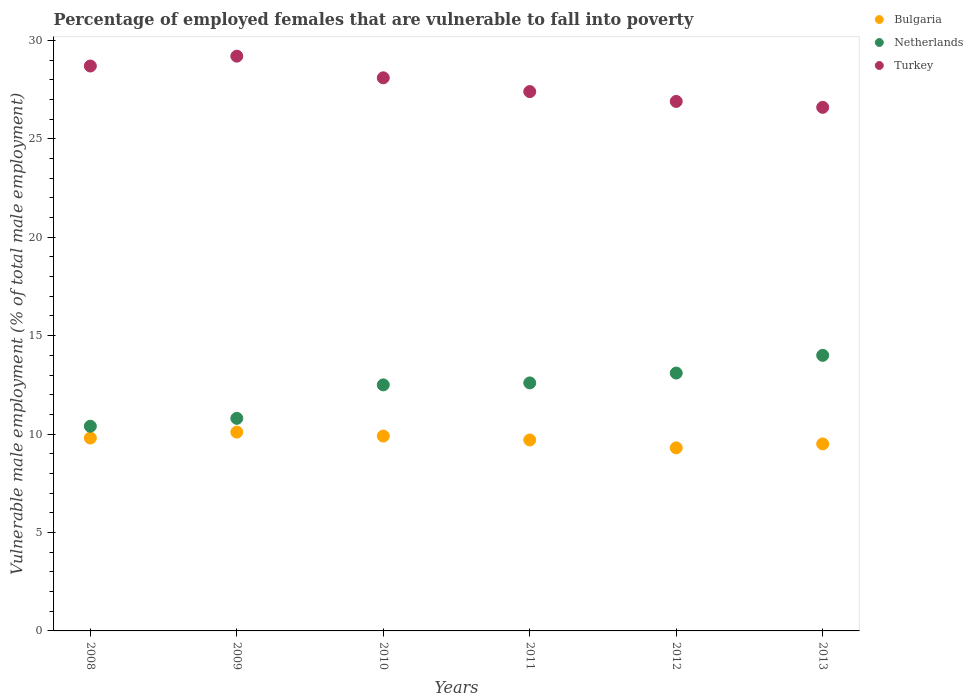How many different coloured dotlines are there?
Your answer should be compact. 3. Is the number of dotlines equal to the number of legend labels?
Your answer should be compact. Yes. What is the percentage of employed females who are vulnerable to fall into poverty in Netherlands in 2011?
Make the answer very short. 12.6. Across all years, what is the minimum percentage of employed females who are vulnerable to fall into poverty in Bulgaria?
Make the answer very short. 9.3. What is the total percentage of employed females who are vulnerable to fall into poverty in Turkey in the graph?
Keep it short and to the point. 166.9. What is the difference between the percentage of employed females who are vulnerable to fall into poverty in Netherlands in 2009 and that in 2013?
Keep it short and to the point. -3.2. What is the difference between the percentage of employed females who are vulnerable to fall into poverty in Netherlands in 2011 and the percentage of employed females who are vulnerable to fall into poverty in Turkey in 2008?
Your answer should be compact. -16.1. What is the average percentage of employed females who are vulnerable to fall into poverty in Netherlands per year?
Your response must be concise. 12.23. In the year 2013, what is the difference between the percentage of employed females who are vulnerable to fall into poverty in Turkey and percentage of employed females who are vulnerable to fall into poverty in Netherlands?
Give a very brief answer. 12.6. In how many years, is the percentage of employed females who are vulnerable to fall into poverty in Bulgaria greater than 5 %?
Offer a very short reply. 6. What is the ratio of the percentage of employed females who are vulnerable to fall into poverty in Netherlands in 2010 to that in 2011?
Your response must be concise. 0.99. Is the difference between the percentage of employed females who are vulnerable to fall into poverty in Turkey in 2011 and 2012 greater than the difference between the percentage of employed females who are vulnerable to fall into poverty in Netherlands in 2011 and 2012?
Ensure brevity in your answer.  Yes. What is the difference between the highest and the second highest percentage of employed females who are vulnerable to fall into poverty in Bulgaria?
Your answer should be very brief. 0.2. What is the difference between the highest and the lowest percentage of employed females who are vulnerable to fall into poverty in Bulgaria?
Offer a terse response. 0.8. Is the percentage of employed females who are vulnerable to fall into poverty in Turkey strictly greater than the percentage of employed females who are vulnerable to fall into poverty in Netherlands over the years?
Offer a terse response. Yes. Is the percentage of employed females who are vulnerable to fall into poverty in Bulgaria strictly less than the percentage of employed females who are vulnerable to fall into poverty in Turkey over the years?
Offer a very short reply. Yes. What is the difference between two consecutive major ticks on the Y-axis?
Offer a terse response. 5. Does the graph contain grids?
Offer a very short reply. No. Where does the legend appear in the graph?
Make the answer very short. Top right. How many legend labels are there?
Give a very brief answer. 3. What is the title of the graph?
Ensure brevity in your answer.  Percentage of employed females that are vulnerable to fall into poverty. Does "Vanuatu" appear as one of the legend labels in the graph?
Give a very brief answer. No. What is the label or title of the X-axis?
Your answer should be very brief. Years. What is the label or title of the Y-axis?
Your answer should be compact. Vulnerable male employment (% of total male employment). What is the Vulnerable male employment (% of total male employment) of Bulgaria in 2008?
Your response must be concise. 9.8. What is the Vulnerable male employment (% of total male employment) in Netherlands in 2008?
Make the answer very short. 10.4. What is the Vulnerable male employment (% of total male employment) in Turkey in 2008?
Offer a very short reply. 28.7. What is the Vulnerable male employment (% of total male employment) in Bulgaria in 2009?
Provide a succinct answer. 10.1. What is the Vulnerable male employment (% of total male employment) of Netherlands in 2009?
Offer a terse response. 10.8. What is the Vulnerable male employment (% of total male employment) in Turkey in 2009?
Offer a very short reply. 29.2. What is the Vulnerable male employment (% of total male employment) in Bulgaria in 2010?
Make the answer very short. 9.9. What is the Vulnerable male employment (% of total male employment) of Netherlands in 2010?
Give a very brief answer. 12.5. What is the Vulnerable male employment (% of total male employment) of Turkey in 2010?
Your answer should be compact. 28.1. What is the Vulnerable male employment (% of total male employment) of Bulgaria in 2011?
Offer a very short reply. 9.7. What is the Vulnerable male employment (% of total male employment) in Netherlands in 2011?
Provide a short and direct response. 12.6. What is the Vulnerable male employment (% of total male employment) in Turkey in 2011?
Provide a succinct answer. 27.4. What is the Vulnerable male employment (% of total male employment) of Bulgaria in 2012?
Provide a short and direct response. 9.3. What is the Vulnerable male employment (% of total male employment) in Netherlands in 2012?
Ensure brevity in your answer.  13.1. What is the Vulnerable male employment (% of total male employment) of Turkey in 2012?
Keep it short and to the point. 26.9. What is the Vulnerable male employment (% of total male employment) of Turkey in 2013?
Your answer should be compact. 26.6. Across all years, what is the maximum Vulnerable male employment (% of total male employment) of Bulgaria?
Ensure brevity in your answer.  10.1. Across all years, what is the maximum Vulnerable male employment (% of total male employment) of Turkey?
Your answer should be compact. 29.2. Across all years, what is the minimum Vulnerable male employment (% of total male employment) of Bulgaria?
Your answer should be compact. 9.3. Across all years, what is the minimum Vulnerable male employment (% of total male employment) of Netherlands?
Offer a terse response. 10.4. Across all years, what is the minimum Vulnerable male employment (% of total male employment) of Turkey?
Your answer should be very brief. 26.6. What is the total Vulnerable male employment (% of total male employment) in Bulgaria in the graph?
Offer a terse response. 58.3. What is the total Vulnerable male employment (% of total male employment) of Netherlands in the graph?
Your response must be concise. 73.4. What is the total Vulnerable male employment (% of total male employment) in Turkey in the graph?
Offer a very short reply. 166.9. What is the difference between the Vulnerable male employment (% of total male employment) in Bulgaria in 2008 and that in 2009?
Make the answer very short. -0.3. What is the difference between the Vulnerable male employment (% of total male employment) of Netherlands in 2008 and that in 2009?
Give a very brief answer. -0.4. What is the difference between the Vulnerable male employment (% of total male employment) in Turkey in 2008 and that in 2009?
Keep it short and to the point. -0.5. What is the difference between the Vulnerable male employment (% of total male employment) in Bulgaria in 2008 and that in 2010?
Offer a terse response. -0.1. What is the difference between the Vulnerable male employment (% of total male employment) of Bulgaria in 2008 and that in 2011?
Offer a very short reply. 0.1. What is the difference between the Vulnerable male employment (% of total male employment) in Turkey in 2008 and that in 2011?
Give a very brief answer. 1.3. What is the difference between the Vulnerable male employment (% of total male employment) in Bulgaria in 2008 and that in 2012?
Ensure brevity in your answer.  0.5. What is the difference between the Vulnerable male employment (% of total male employment) in Netherlands in 2008 and that in 2013?
Give a very brief answer. -3.6. What is the difference between the Vulnerable male employment (% of total male employment) of Bulgaria in 2009 and that in 2010?
Your answer should be very brief. 0.2. What is the difference between the Vulnerable male employment (% of total male employment) in Netherlands in 2009 and that in 2010?
Your answer should be very brief. -1.7. What is the difference between the Vulnerable male employment (% of total male employment) in Netherlands in 2009 and that in 2013?
Keep it short and to the point. -3.2. What is the difference between the Vulnerable male employment (% of total male employment) in Turkey in 2009 and that in 2013?
Provide a succinct answer. 2.6. What is the difference between the Vulnerable male employment (% of total male employment) of Bulgaria in 2010 and that in 2011?
Your answer should be very brief. 0.2. What is the difference between the Vulnerable male employment (% of total male employment) in Netherlands in 2010 and that in 2011?
Offer a terse response. -0.1. What is the difference between the Vulnerable male employment (% of total male employment) of Bulgaria in 2010 and that in 2012?
Offer a very short reply. 0.6. What is the difference between the Vulnerable male employment (% of total male employment) of Netherlands in 2010 and that in 2012?
Your answer should be very brief. -0.6. What is the difference between the Vulnerable male employment (% of total male employment) of Netherlands in 2010 and that in 2013?
Your answer should be compact. -1.5. What is the difference between the Vulnerable male employment (% of total male employment) of Netherlands in 2011 and that in 2012?
Your answer should be very brief. -0.5. What is the difference between the Vulnerable male employment (% of total male employment) in Netherlands in 2012 and that in 2013?
Give a very brief answer. -0.9. What is the difference between the Vulnerable male employment (% of total male employment) in Bulgaria in 2008 and the Vulnerable male employment (% of total male employment) in Turkey in 2009?
Give a very brief answer. -19.4. What is the difference between the Vulnerable male employment (% of total male employment) of Netherlands in 2008 and the Vulnerable male employment (% of total male employment) of Turkey in 2009?
Make the answer very short. -18.8. What is the difference between the Vulnerable male employment (% of total male employment) of Bulgaria in 2008 and the Vulnerable male employment (% of total male employment) of Netherlands in 2010?
Your response must be concise. -2.7. What is the difference between the Vulnerable male employment (% of total male employment) in Bulgaria in 2008 and the Vulnerable male employment (% of total male employment) in Turkey in 2010?
Offer a terse response. -18.3. What is the difference between the Vulnerable male employment (% of total male employment) of Netherlands in 2008 and the Vulnerable male employment (% of total male employment) of Turkey in 2010?
Offer a terse response. -17.7. What is the difference between the Vulnerable male employment (% of total male employment) of Bulgaria in 2008 and the Vulnerable male employment (% of total male employment) of Netherlands in 2011?
Give a very brief answer. -2.8. What is the difference between the Vulnerable male employment (% of total male employment) in Bulgaria in 2008 and the Vulnerable male employment (% of total male employment) in Turkey in 2011?
Provide a succinct answer. -17.6. What is the difference between the Vulnerable male employment (% of total male employment) of Netherlands in 2008 and the Vulnerable male employment (% of total male employment) of Turkey in 2011?
Your response must be concise. -17. What is the difference between the Vulnerable male employment (% of total male employment) in Bulgaria in 2008 and the Vulnerable male employment (% of total male employment) in Netherlands in 2012?
Provide a short and direct response. -3.3. What is the difference between the Vulnerable male employment (% of total male employment) of Bulgaria in 2008 and the Vulnerable male employment (% of total male employment) of Turkey in 2012?
Your response must be concise. -17.1. What is the difference between the Vulnerable male employment (% of total male employment) in Netherlands in 2008 and the Vulnerable male employment (% of total male employment) in Turkey in 2012?
Offer a very short reply. -16.5. What is the difference between the Vulnerable male employment (% of total male employment) of Bulgaria in 2008 and the Vulnerable male employment (% of total male employment) of Netherlands in 2013?
Ensure brevity in your answer.  -4.2. What is the difference between the Vulnerable male employment (% of total male employment) of Bulgaria in 2008 and the Vulnerable male employment (% of total male employment) of Turkey in 2013?
Provide a succinct answer. -16.8. What is the difference between the Vulnerable male employment (% of total male employment) in Netherlands in 2008 and the Vulnerable male employment (% of total male employment) in Turkey in 2013?
Your answer should be very brief. -16.2. What is the difference between the Vulnerable male employment (% of total male employment) of Netherlands in 2009 and the Vulnerable male employment (% of total male employment) of Turkey in 2010?
Ensure brevity in your answer.  -17.3. What is the difference between the Vulnerable male employment (% of total male employment) of Bulgaria in 2009 and the Vulnerable male employment (% of total male employment) of Turkey in 2011?
Offer a terse response. -17.3. What is the difference between the Vulnerable male employment (% of total male employment) of Netherlands in 2009 and the Vulnerable male employment (% of total male employment) of Turkey in 2011?
Provide a succinct answer. -16.6. What is the difference between the Vulnerable male employment (% of total male employment) of Bulgaria in 2009 and the Vulnerable male employment (% of total male employment) of Netherlands in 2012?
Offer a very short reply. -3. What is the difference between the Vulnerable male employment (% of total male employment) in Bulgaria in 2009 and the Vulnerable male employment (% of total male employment) in Turkey in 2012?
Offer a very short reply. -16.8. What is the difference between the Vulnerable male employment (% of total male employment) in Netherlands in 2009 and the Vulnerable male employment (% of total male employment) in Turkey in 2012?
Your answer should be compact. -16.1. What is the difference between the Vulnerable male employment (% of total male employment) of Bulgaria in 2009 and the Vulnerable male employment (% of total male employment) of Turkey in 2013?
Provide a short and direct response. -16.5. What is the difference between the Vulnerable male employment (% of total male employment) in Netherlands in 2009 and the Vulnerable male employment (% of total male employment) in Turkey in 2013?
Your answer should be compact. -15.8. What is the difference between the Vulnerable male employment (% of total male employment) of Bulgaria in 2010 and the Vulnerable male employment (% of total male employment) of Turkey in 2011?
Your answer should be very brief. -17.5. What is the difference between the Vulnerable male employment (% of total male employment) of Netherlands in 2010 and the Vulnerable male employment (% of total male employment) of Turkey in 2011?
Offer a terse response. -14.9. What is the difference between the Vulnerable male employment (% of total male employment) in Bulgaria in 2010 and the Vulnerable male employment (% of total male employment) in Turkey in 2012?
Your response must be concise. -17. What is the difference between the Vulnerable male employment (% of total male employment) in Netherlands in 2010 and the Vulnerable male employment (% of total male employment) in Turkey in 2012?
Keep it short and to the point. -14.4. What is the difference between the Vulnerable male employment (% of total male employment) of Bulgaria in 2010 and the Vulnerable male employment (% of total male employment) of Turkey in 2013?
Your answer should be very brief. -16.7. What is the difference between the Vulnerable male employment (% of total male employment) in Netherlands in 2010 and the Vulnerable male employment (% of total male employment) in Turkey in 2013?
Your answer should be compact. -14.1. What is the difference between the Vulnerable male employment (% of total male employment) in Bulgaria in 2011 and the Vulnerable male employment (% of total male employment) in Turkey in 2012?
Your response must be concise. -17.2. What is the difference between the Vulnerable male employment (% of total male employment) of Netherlands in 2011 and the Vulnerable male employment (% of total male employment) of Turkey in 2012?
Your answer should be compact. -14.3. What is the difference between the Vulnerable male employment (% of total male employment) of Bulgaria in 2011 and the Vulnerable male employment (% of total male employment) of Netherlands in 2013?
Ensure brevity in your answer.  -4.3. What is the difference between the Vulnerable male employment (% of total male employment) of Bulgaria in 2011 and the Vulnerable male employment (% of total male employment) of Turkey in 2013?
Your answer should be compact. -16.9. What is the difference between the Vulnerable male employment (% of total male employment) of Netherlands in 2011 and the Vulnerable male employment (% of total male employment) of Turkey in 2013?
Provide a succinct answer. -14. What is the difference between the Vulnerable male employment (% of total male employment) in Bulgaria in 2012 and the Vulnerable male employment (% of total male employment) in Turkey in 2013?
Give a very brief answer. -17.3. What is the difference between the Vulnerable male employment (% of total male employment) in Netherlands in 2012 and the Vulnerable male employment (% of total male employment) in Turkey in 2013?
Keep it short and to the point. -13.5. What is the average Vulnerable male employment (% of total male employment) of Bulgaria per year?
Offer a terse response. 9.72. What is the average Vulnerable male employment (% of total male employment) in Netherlands per year?
Give a very brief answer. 12.23. What is the average Vulnerable male employment (% of total male employment) in Turkey per year?
Ensure brevity in your answer.  27.82. In the year 2008, what is the difference between the Vulnerable male employment (% of total male employment) in Bulgaria and Vulnerable male employment (% of total male employment) in Netherlands?
Provide a short and direct response. -0.6. In the year 2008, what is the difference between the Vulnerable male employment (% of total male employment) of Bulgaria and Vulnerable male employment (% of total male employment) of Turkey?
Keep it short and to the point. -18.9. In the year 2008, what is the difference between the Vulnerable male employment (% of total male employment) of Netherlands and Vulnerable male employment (% of total male employment) of Turkey?
Offer a very short reply. -18.3. In the year 2009, what is the difference between the Vulnerable male employment (% of total male employment) in Bulgaria and Vulnerable male employment (% of total male employment) in Turkey?
Keep it short and to the point. -19.1. In the year 2009, what is the difference between the Vulnerable male employment (% of total male employment) in Netherlands and Vulnerable male employment (% of total male employment) in Turkey?
Provide a short and direct response. -18.4. In the year 2010, what is the difference between the Vulnerable male employment (% of total male employment) of Bulgaria and Vulnerable male employment (% of total male employment) of Turkey?
Ensure brevity in your answer.  -18.2. In the year 2010, what is the difference between the Vulnerable male employment (% of total male employment) in Netherlands and Vulnerable male employment (% of total male employment) in Turkey?
Your answer should be compact. -15.6. In the year 2011, what is the difference between the Vulnerable male employment (% of total male employment) of Bulgaria and Vulnerable male employment (% of total male employment) of Netherlands?
Keep it short and to the point. -2.9. In the year 2011, what is the difference between the Vulnerable male employment (% of total male employment) of Bulgaria and Vulnerable male employment (% of total male employment) of Turkey?
Keep it short and to the point. -17.7. In the year 2011, what is the difference between the Vulnerable male employment (% of total male employment) of Netherlands and Vulnerable male employment (% of total male employment) of Turkey?
Your answer should be compact. -14.8. In the year 2012, what is the difference between the Vulnerable male employment (% of total male employment) in Bulgaria and Vulnerable male employment (% of total male employment) in Turkey?
Give a very brief answer. -17.6. In the year 2012, what is the difference between the Vulnerable male employment (% of total male employment) of Netherlands and Vulnerable male employment (% of total male employment) of Turkey?
Keep it short and to the point. -13.8. In the year 2013, what is the difference between the Vulnerable male employment (% of total male employment) in Bulgaria and Vulnerable male employment (% of total male employment) in Turkey?
Make the answer very short. -17.1. What is the ratio of the Vulnerable male employment (% of total male employment) of Bulgaria in 2008 to that in 2009?
Your answer should be compact. 0.97. What is the ratio of the Vulnerable male employment (% of total male employment) in Netherlands in 2008 to that in 2009?
Give a very brief answer. 0.96. What is the ratio of the Vulnerable male employment (% of total male employment) of Turkey in 2008 to that in 2009?
Offer a terse response. 0.98. What is the ratio of the Vulnerable male employment (% of total male employment) in Netherlands in 2008 to that in 2010?
Offer a very short reply. 0.83. What is the ratio of the Vulnerable male employment (% of total male employment) of Turkey in 2008 to that in 2010?
Provide a short and direct response. 1.02. What is the ratio of the Vulnerable male employment (% of total male employment) in Bulgaria in 2008 to that in 2011?
Keep it short and to the point. 1.01. What is the ratio of the Vulnerable male employment (% of total male employment) of Netherlands in 2008 to that in 2011?
Give a very brief answer. 0.83. What is the ratio of the Vulnerable male employment (% of total male employment) of Turkey in 2008 to that in 2011?
Provide a short and direct response. 1.05. What is the ratio of the Vulnerable male employment (% of total male employment) in Bulgaria in 2008 to that in 2012?
Offer a very short reply. 1.05. What is the ratio of the Vulnerable male employment (% of total male employment) of Netherlands in 2008 to that in 2012?
Ensure brevity in your answer.  0.79. What is the ratio of the Vulnerable male employment (% of total male employment) in Turkey in 2008 to that in 2012?
Provide a succinct answer. 1.07. What is the ratio of the Vulnerable male employment (% of total male employment) of Bulgaria in 2008 to that in 2013?
Give a very brief answer. 1.03. What is the ratio of the Vulnerable male employment (% of total male employment) of Netherlands in 2008 to that in 2013?
Offer a terse response. 0.74. What is the ratio of the Vulnerable male employment (% of total male employment) of Turkey in 2008 to that in 2013?
Your answer should be compact. 1.08. What is the ratio of the Vulnerable male employment (% of total male employment) of Bulgaria in 2009 to that in 2010?
Your response must be concise. 1.02. What is the ratio of the Vulnerable male employment (% of total male employment) of Netherlands in 2009 to that in 2010?
Make the answer very short. 0.86. What is the ratio of the Vulnerable male employment (% of total male employment) in Turkey in 2009 to that in 2010?
Offer a terse response. 1.04. What is the ratio of the Vulnerable male employment (% of total male employment) of Bulgaria in 2009 to that in 2011?
Your answer should be very brief. 1.04. What is the ratio of the Vulnerable male employment (% of total male employment) in Turkey in 2009 to that in 2011?
Offer a very short reply. 1.07. What is the ratio of the Vulnerable male employment (% of total male employment) in Bulgaria in 2009 to that in 2012?
Offer a terse response. 1.09. What is the ratio of the Vulnerable male employment (% of total male employment) of Netherlands in 2009 to that in 2012?
Provide a succinct answer. 0.82. What is the ratio of the Vulnerable male employment (% of total male employment) of Turkey in 2009 to that in 2012?
Keep it short and to the point. 1.09. What is the ratio of the Vulnerable male employment (% of total male employment) of Bulgaria in 2009 to that in 2013?
Ensure brevity in your answer.  1.06. What is the ratio of the Vulnerable male employment (% of total male employment) in Netherlands in 2009 to that in 2013?
Keep it short and to the point. 0.77. What is the ratio of the Vulnerable male employment (% of total male employment) in Turkey in 2009 to that in 2013?
Ensure brevity in your answer.  1.1. What is the ratio of the Vulnerable male employment (% of total male employment) in Bulgaria in 2010 to that in 2011?
Provide a short and direct response. 1.02. What is the ratio of the Vulnerable male employment (% of total male employment) in Turkey in 2010 to that in 2011?
Provide a succinct answer. 1.03. What is the ratio of the Vulnerable male employment (% of total male employment) in Bulgaria in 2010 to that in 2012?
Provide a succinct answer. 1.06. What is the ratio of the Vulnerable male employment (% of total male employment) of Netherlands in 2010 to that in 2012?
Provide a succinct answer. 0.95. What is the ratio of the Vulnerable male employment (% of total male employment) in Turkey in 2010 to that in 2012?
Make the answer very short. 1.04. What is the ratio of the Vulnerable male employment (% of total male employment) of Bulgaria in 2010 to that in 2013?
Your answer should be compact. 1.04. What is the ratio of the Vulnerable male employment (% of total male employment) of Netherlands in 2010 to that in 2013?
Provide a succinct answer. 0.89. What is the ratio of the Vulnerable male employment (% of total male employment) in Turkey in 2010 to that in 2013?
Keep it short and to the point. 1.06. What is the ratio of the Vulnerable male employment (% of total male employment) in Bulgaria in 2011 to that in 2012?
Your answer should be compact. 1.04. What is the ratio of the Vulnerable male employment (% of total male employment) in Netherlands in 2011 to that in 2012?
Make the answer very short. 0.96. What is the ratio of the Vulnerable male employment (% of total male employment) in Turkey in 2011 to that in 2012?
Your answer should be compact. 1.02. What is the ratio of the Vulnerable male employment (% of total male employment) in Bulgaria in 2011 to that in 2013?
Ensure brevity in your answer.  1.02. What is the ratio of the Vulnerable male employment (% of total male employment) in Netherlands in 2011 to that in 2013?
Ensure brevity in your answer.  0.9. What is the ratio of the Vulnerable male employment (% of total male employment) of Turkey in 2011 to that in 2013?
Offer a terse response. 1.03. What is the ratio of the Vulnerable male employment (% of total male employment) in Bulgaria in 2012 to that in 2013?
Keep it short and to the point. 0.98. What is the ratio of the Vulnerable male employment (% of total male employment) in Netherlands in 2012 to that in 2013?
Your answer should be very brief. 0.94. What is the ratio of the Vulnerable male employment (% of total male employment) in Turkey in 2012 to that in 2013?
Your answer should be very brief. 1.01. What is the difference between the highest and the second highest Vulnerable male employment (% of total male employment) of Netherlands?
Your response must be concise. 0.9. What is the difference between the highest and the second highest Vulnerable male employment (% of total male employment) in Turkey?
Your answer should be very brief. 0.5. What is the difference between the highest and the lowest Vulnerable male employment (% of total male employment) of Bulgaria?
Your answer should be very brief. 0.8. What is the difference between the highest and the lowest Vulnerable male employment (% of total male employment) in Netherlands?
Give a very brief answer. 3.6. What is the difference between the highest and the lowest Vulnerable male employment (% of total male employment) in Turkey?
Offer a terse response. 2.6. 